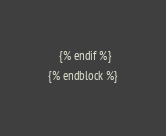Convert code to text. <code><loc_0><loc_0><loc_500><loc_500><_HTML_>    {% endif %}
{% endblock %}
</code> 